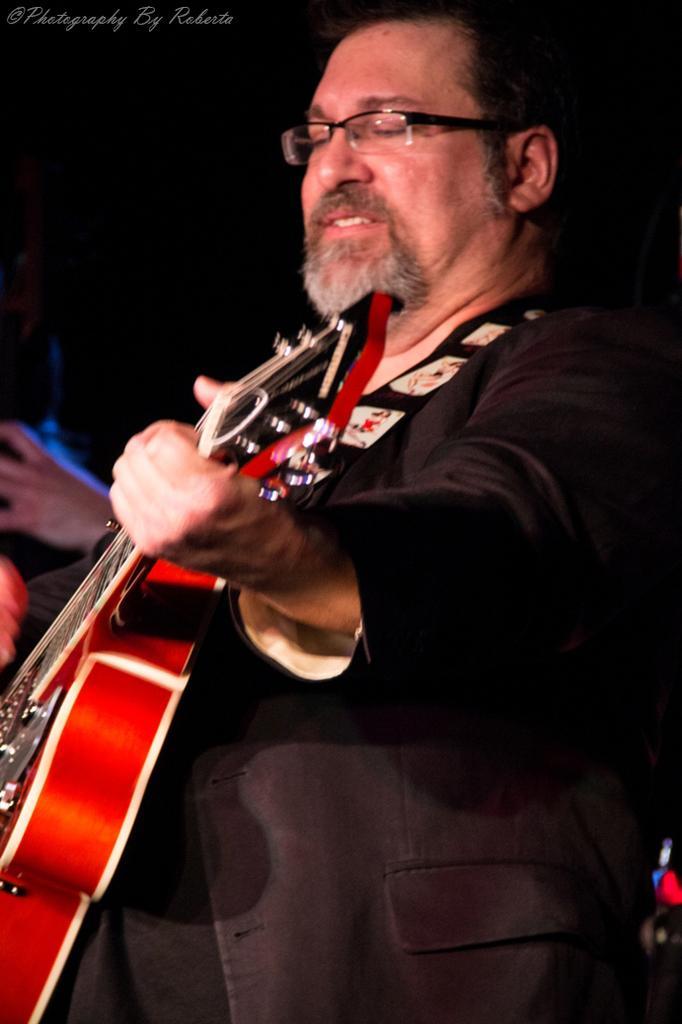Can you describe this image briefly? In a picture there is one man playing a guitar and wearing a black suit. 